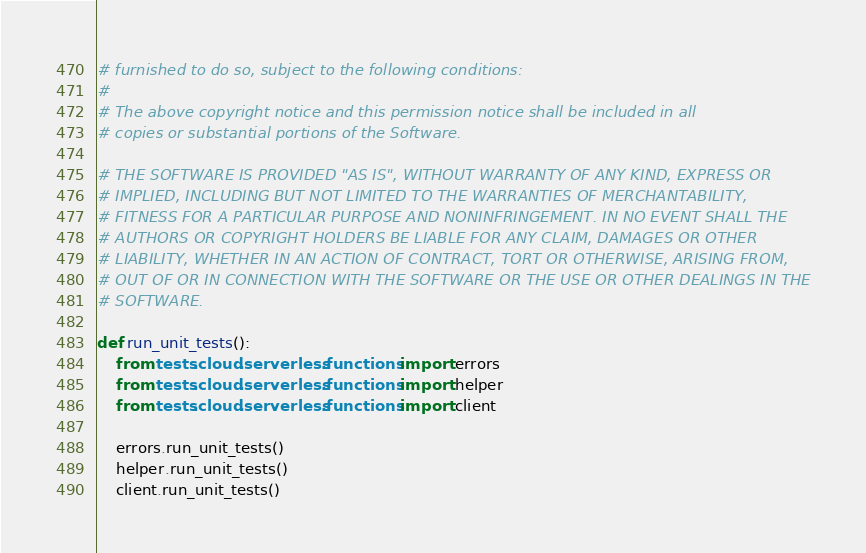Convert code to text. <code><loc_0><loc_0><loc_500><loc_500><_Python_># furnished to do so, subject to the following conditions:
# 
# The above copyright notice and this permission notice shall be included in all
# copies or substantial portions of the Software.

# THE SOFTWARE IS PROVIDED "AS IS", WITHOUT WARRANTY OF ANY KIND, EXPRESS OR
# IMPLIED, INCLUDING BUT NOT LIMITED TO THE WARRANTIES OF MERCHANTABILITY,
# FITNESS FOR A PARTICULAR PURPOSE AND NONINFRINGEMENT. IN NO EVENT SHALL THE
# AUTHORS OR COPYRIGHT HOLDERS BE LIABLE FOR ANY CLAIM, DAMAGES OR OTHER
# LIABILITY, WHETHER IN AN ACTION OF CONTRACT, TORT OR OTHERWISE, ARISING FROM,
# OUT OF OR IN CONNECTION WITH THE SOFTWARE OR THE USE OR OTHER DEALINGS IN THE
# SOFTWARE.

def run_unit_tests():
    from tests.cloud.serverless.functions import errors
    from tests.cloud.serverless.functions import helper
    from tests.cloud.serverless.functions import client

    errors.run_unit_tests()
    helper.run_unit_tests()
    client.run_unit_tests()
</code> 